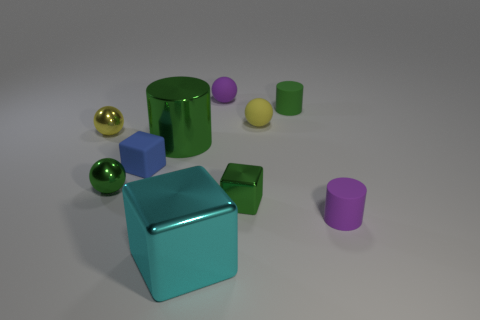There is a cube that is both to the left of the small green block and behind the purple cylinder; how big is it?
Keep it short and to the point. Small. Does the shiny cylinder have the same color as the tiny rubber cylinder that is in front of the small green matte cylinder?
Offer a terse response. No. What number of brown objects are small cubes or balls?
Give a very brief answer. 0. What is the shape of the small yellow matte object?
Provide a short and direct response. Sphere. How many other objects are there of the same shape as the large green object?
Provide a short and direct response. 2. There is a matte cylinder in front of the small blue rubber block; what color is it?
Give a very brief answer. Purple. Does the large cyan cube have the same material as the small purple ball?
Your answer should be very brief. No. How many things are either large blue matte objects or green things right of the blue matte thing?
Provide a short and direct response. 3. The matte cylinder that is the same color as the small metal block is what size?
Provide a succinct answer. Small. There is a big object that is in front of the tiny blue thing; what is its shape?
Keep it short and to the point. Cube. 